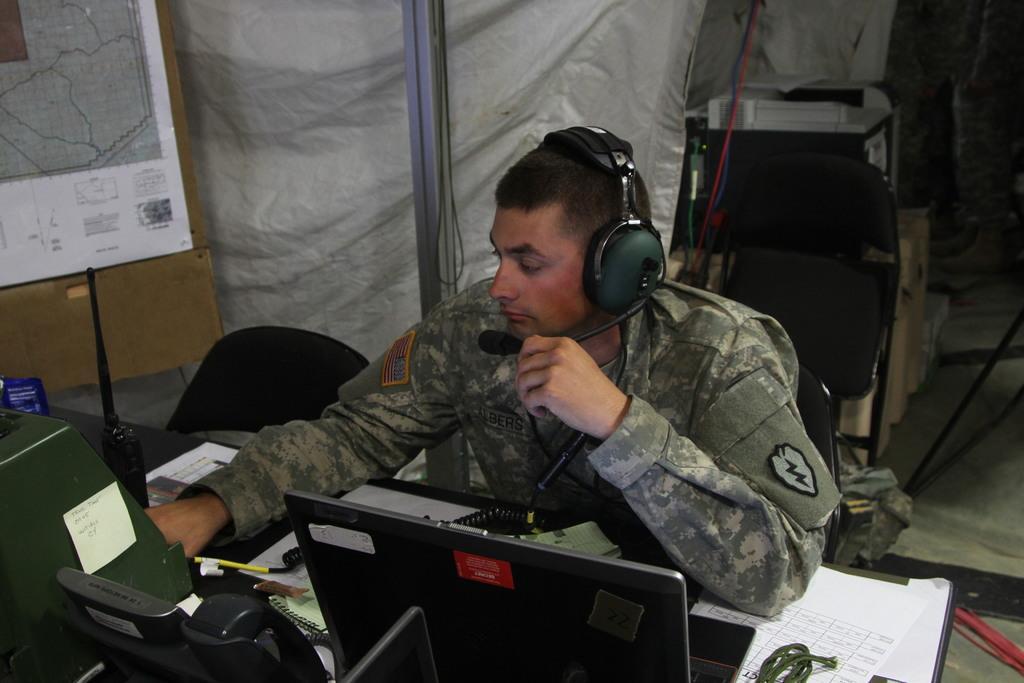Can you describe this image briefly? This is the picture of a person who is wearing the headset and sitting on the chair in front of the table on which there is a laptop, phone, paper, pen and some things and also we can see some other things around. 